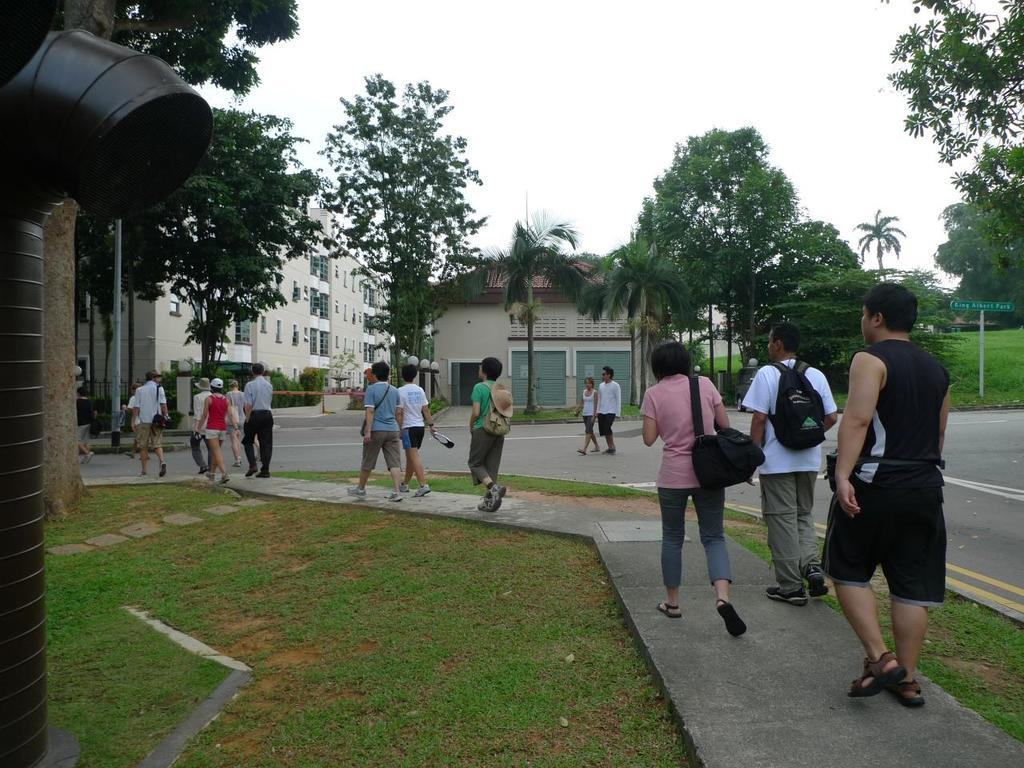How many people are in the image? There is a group of people standing in the image. What objects can be seen in the image besides the people? There are poles, a board, a pipe, plants, grass, trees, houses, and shutters visible in the image. What type of vegetation is present in the image? There are plants, grass, and trees in the image. What type of structures can be seen in the image? There are houses in the image. What architectural feature can be seen on the houses? There are shutters on the houses. What is visible in the background of the image? The sky is visible in the background of the image. What type of oil is being used to heat the battle in the image? There is no battle or oil present in the image. 